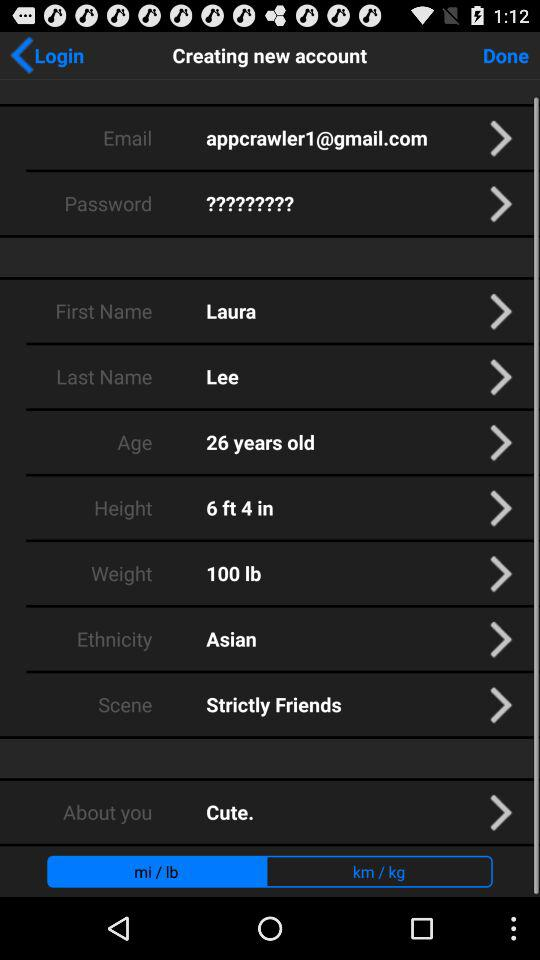What is the given age? The given age is 26 years. 